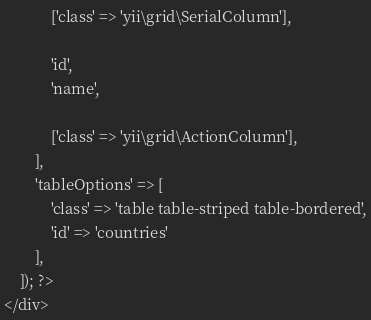Convert code to text. <code><loc_0><loc_0><loc_500><loc_500><_PHP_>            ['class' => 'yii\grid\SerialColumn'],

            'id',
            'name',

            ['class' => 'yii\grid\ActionColumn'],
        ],
        'tableOptions' => [
            'class' => 'table table-striped table-bordered',
            'id' => 'countries'
        ],
    ]); ?>
</div>
</code> 